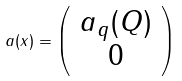Convert formula to latex. <formula><loc_0><loc_0><loc_500><loc_500>a ( x ) = \left ( \begin{array} { c } a _ { q } ( Q ) \\ 0 \end{array} \right ) \\</formula> 